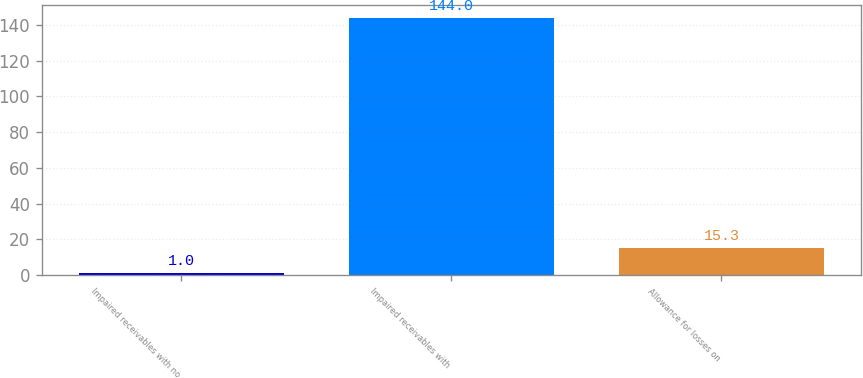Convert chart. <chart><loc_0><loc_0><loc_500><loc_500><bar_chart><fcel>Impaired receivables with no<fcel>Impaired receivables with<fcel>Allowance for losses on<nl><fcel>1<fcel>144<fcel>15.3<nl></chart> 